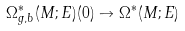<formula> <loc_0><loc_0><loc_500><loc_500>\Omega ^ { * } _ { g , b } ( M ; E ) ( 0 ) \to \Omega ^ { * } ( M ; E )</formula> 